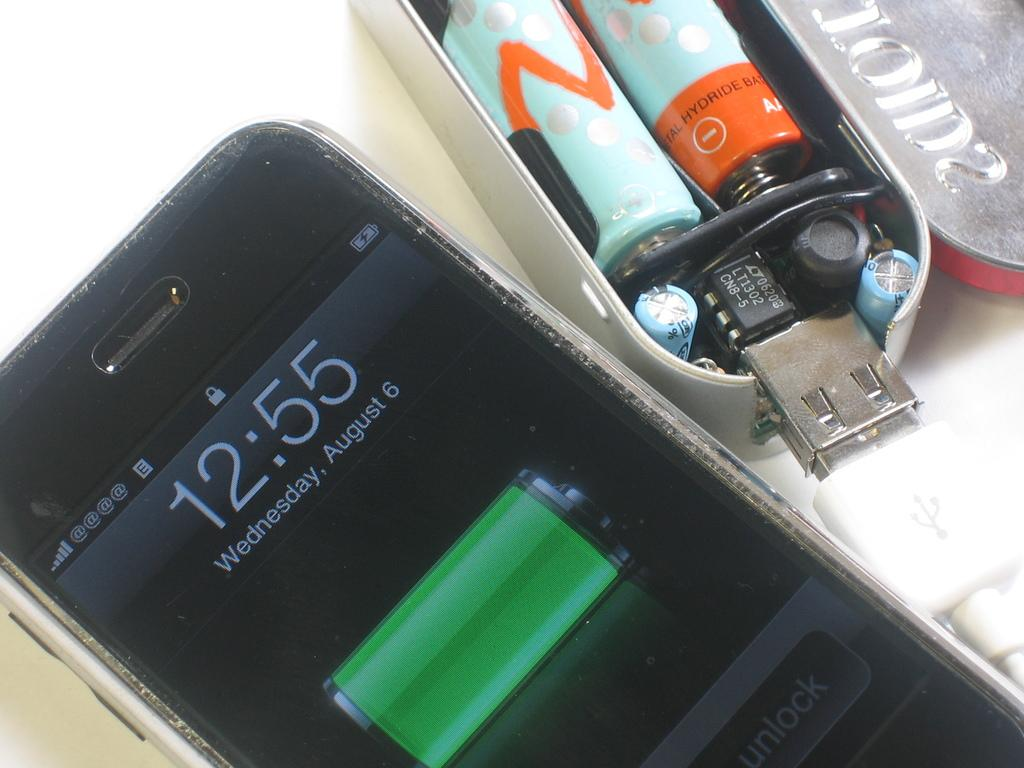<image>
Share a concise interpretation of the image provided. A black iPhone shows that on Wednesday, August 6th the time is 12:55. 